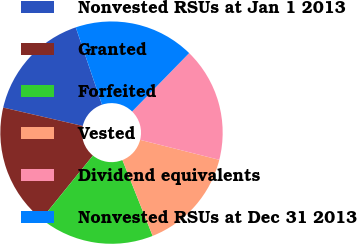Convert chart. <chart><loc_0><loc_0><loc_500><loc_500><pie_chart><fcel>Nonvested RSUs at Jan 1 2013<fcel>Granted<fcel>Forfeited<fcel>Vested<fcel>Dividend equivalents<fcel>Nonvested RSUs at Dec 31 2013<nl><fcel>16.17%<fcel>17.78%<fcel>16.87%<fcel>15.03%<fcel>16.62%<fcel>17.52%<nl></chart> 